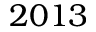Convert formula to latex. <formula><loc_0><loc_0><loc_500><loc_500>2 0 1 3</formula> 